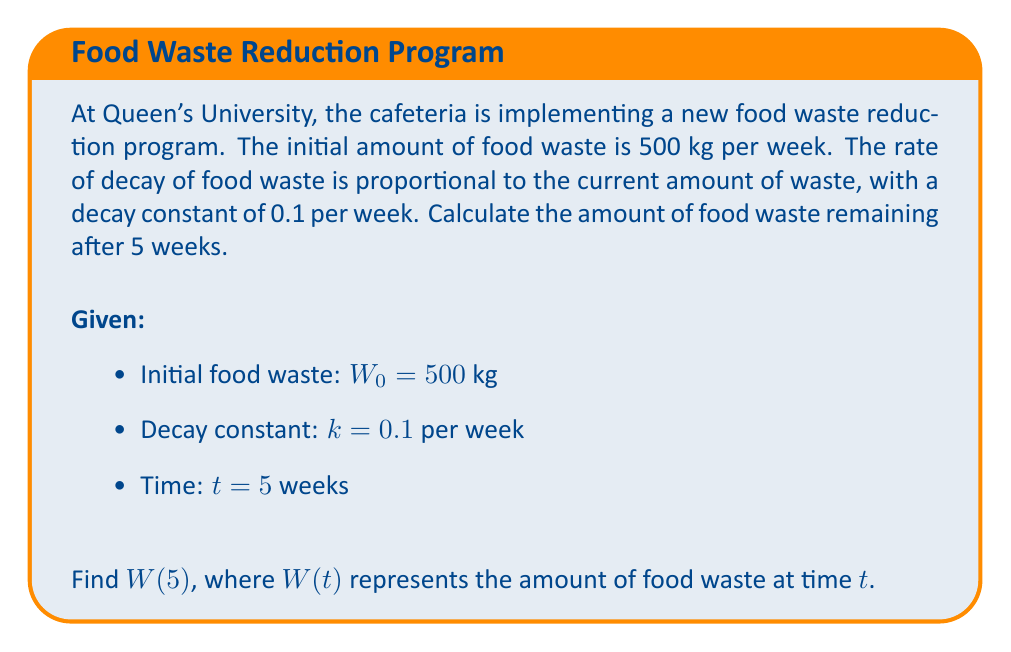Solve this math problem. To solve this problem, we'll use the first-order differential equation for exponential decay:

1) The general form of the equation is:
   $$\frac{dW}{dt} = -kW$$

2) The solution to this equation is:
   $$W(t) = W_0e^{-kt}$$
   where $W_0$ is the initial amount and $k$ is the decay constant.

3) We're given:
   $W_0 = 500$ kg
   $k = 0.1$ per week
   $t = 5$ weeks

4) Substituting these values into the equation:
   $$W(5) = 500e^{-0.1 \cdot 5}$$

5) Simplify:
   $$W(5) = 500e^{-0.5}$$

6) Calculate:
   $$W(5) \approx 303.27$$ kg

Therefore, after 5 weeks, approximately 303.27 kg of food waste remains.
Answer: $303.27$ kg 